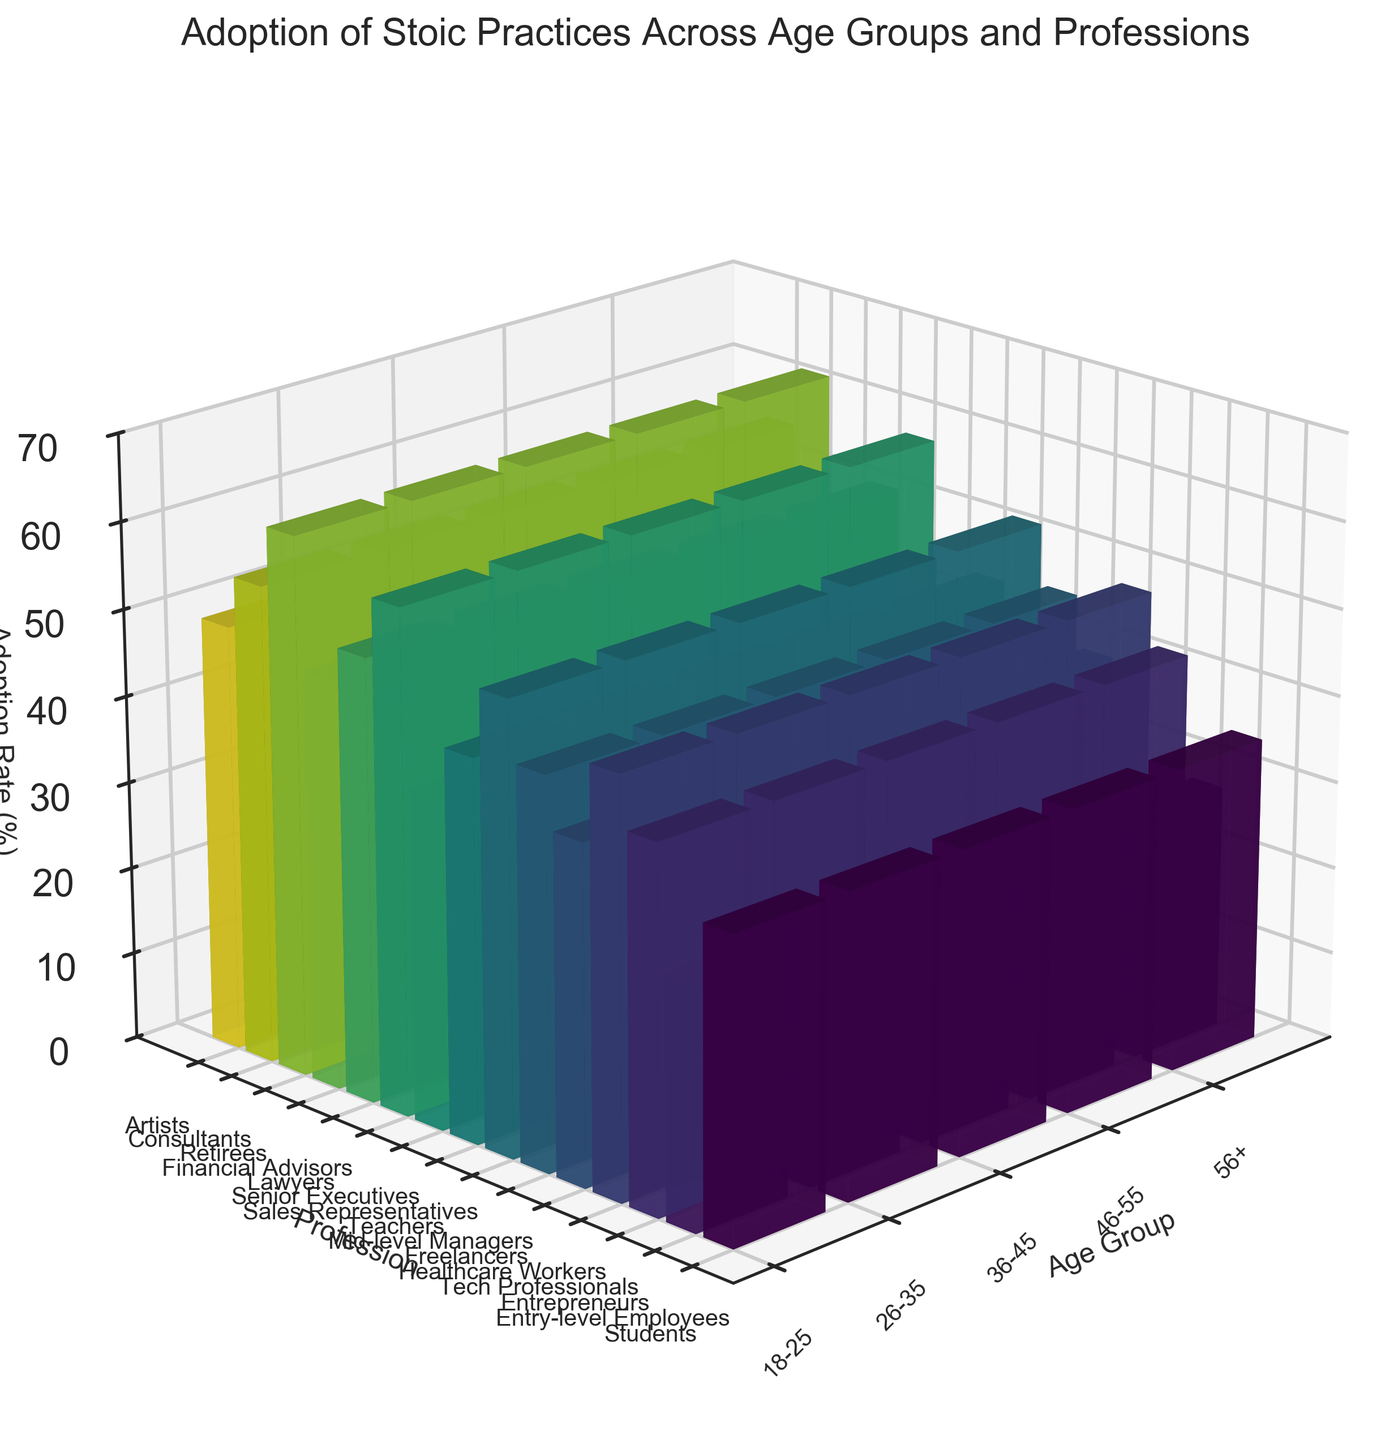What's the title of the figure? The title is located at the top of the figure and summarizes the content of the plot. In this case, the title is "Adoption of Stoic Practices Across Age Groups and Professions".
Answer: Adoption of Stoic Practices Across Age Groups and Professions Which age group has the highest adoption rate of stoic practices among retirees? The bar representing retirees in the '56+' age group rises to 62%, indicating the highest adoption rate among retirees across all age groups.
Answer: 56+ What is the adoption rate of stoic practices for tech professionals in the 26-35 age group? Locate the bar for 'Tech Professionals' in the corresponding age group (26-35). This bar rises to a height of 48%.
Answer: 48% Which profession shows the lowest adoption rate of stoic practices in the 18-25 age group? Among the bars in the 18-25 age group, 'Entry-level Employees' shows the lowest adoption rate, corresponding to a height of 28%.
Answer: Entry-level Employees Compare the adoption rates of stoic practices for freelancers and teachers. Which profession has a higher rate, and by how much? Locate the bars for 'Freelancers' (26-35 age group) and 'Teachers' (36-45 age group). Freelancers have an adoption rate of 45%, while Teachers have 44%. The difference is 1%.
Answer: Freelancers by 1% What is the average adoption rate of stoic practices among the 46-55 age group? Calculate the average by summing the adoption rates for 'Senior Executives' (58), 'Lawyers' (51), and 'Financial Advisors' (47), and then divide by the number of professions (3). Sum = 156, so Average = 156/3 = 52%.
Answer: 52% Which profession shows a higher adoption rate of stoic practices, Consultants or Artists, in the 56+ age group, and what is the difference? Compare the heights of the bars representing 'Consultants' (55%) and 'Artists' (49%). Consultants have a higher rate, with a difference of 6%.
Answer: Consultants by 6% What is the difference between the highest and lowest adoption rates in the 18-25 age group? Identify the highest (Entrepreneurs, 42%) and lowest (Entry-level Employees, 28%) bars in the 18-25 age group. The difference is 42 - 28 = 14%.
Answer: 14% Which age group exhibits the overall highest adoption rates of stoic practices? Observe the bars closely and determine that the '56+' age group generally has taller bars compared to other age groups.
Answer: 56+ 